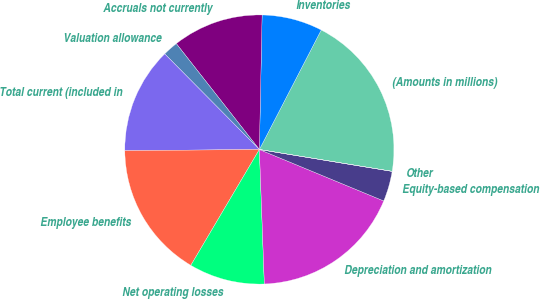Convert chart to OTSL. <chart><loc_0><loc_0><loc_500><loc_500><pie_chart><fcel>(Amounts in millions)<fcel>Inventories<fcel>Accruals not currently<fcel>Valuation allowance<fcel>Total current (included in<fcel>Employee benefits<fcel>Net operating losses<fcel>Depreciation and amortization<fcel>Equity-based compensation<fcel>Other<nl><fcel>19.99%<fcel>7.28%<fcel>10.91%<fcel>1.83%<fcel>12.72%<fcel>16.36%<fcel>9.09%<fcel>18.17%<fcel>3.64%<fcel>0.01%<nl></chart> 